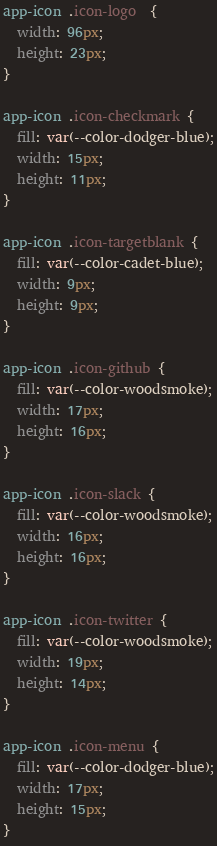Convert code to text. <code><loc_0><loc_0><loc_500><loc_500><_CSS_>
app-icon .icon-logo  {
  width: 96px;
  height: 23px;
}

app-icon .icon-checkmark {
  fill: var(--color-dodger-blue);
  width: 15px;
  height: 11px;
}

app-icon .icon-targetblank {
  fill: var(--color-cadet-blue);
  width: 9px;
  height: 9px;
}

app-icon .icon-github {
  fill: var(--color-woodsmoke);
  width: 17px;
  height: 16px;
}

app-icon .icon-slack {
  fill: var(--color-woodsmoke);
  width: 16px;
  height: 16px;
}

app-icon .icon-twitter {
  fill: var(--color-woodsmoke);
  width: 19px;
  height: 14px;
}

app-icon .icon-menu {
  fill: var(--color-dodger-blue);
  width: 17px;
  height: 15px;
}
</code> 